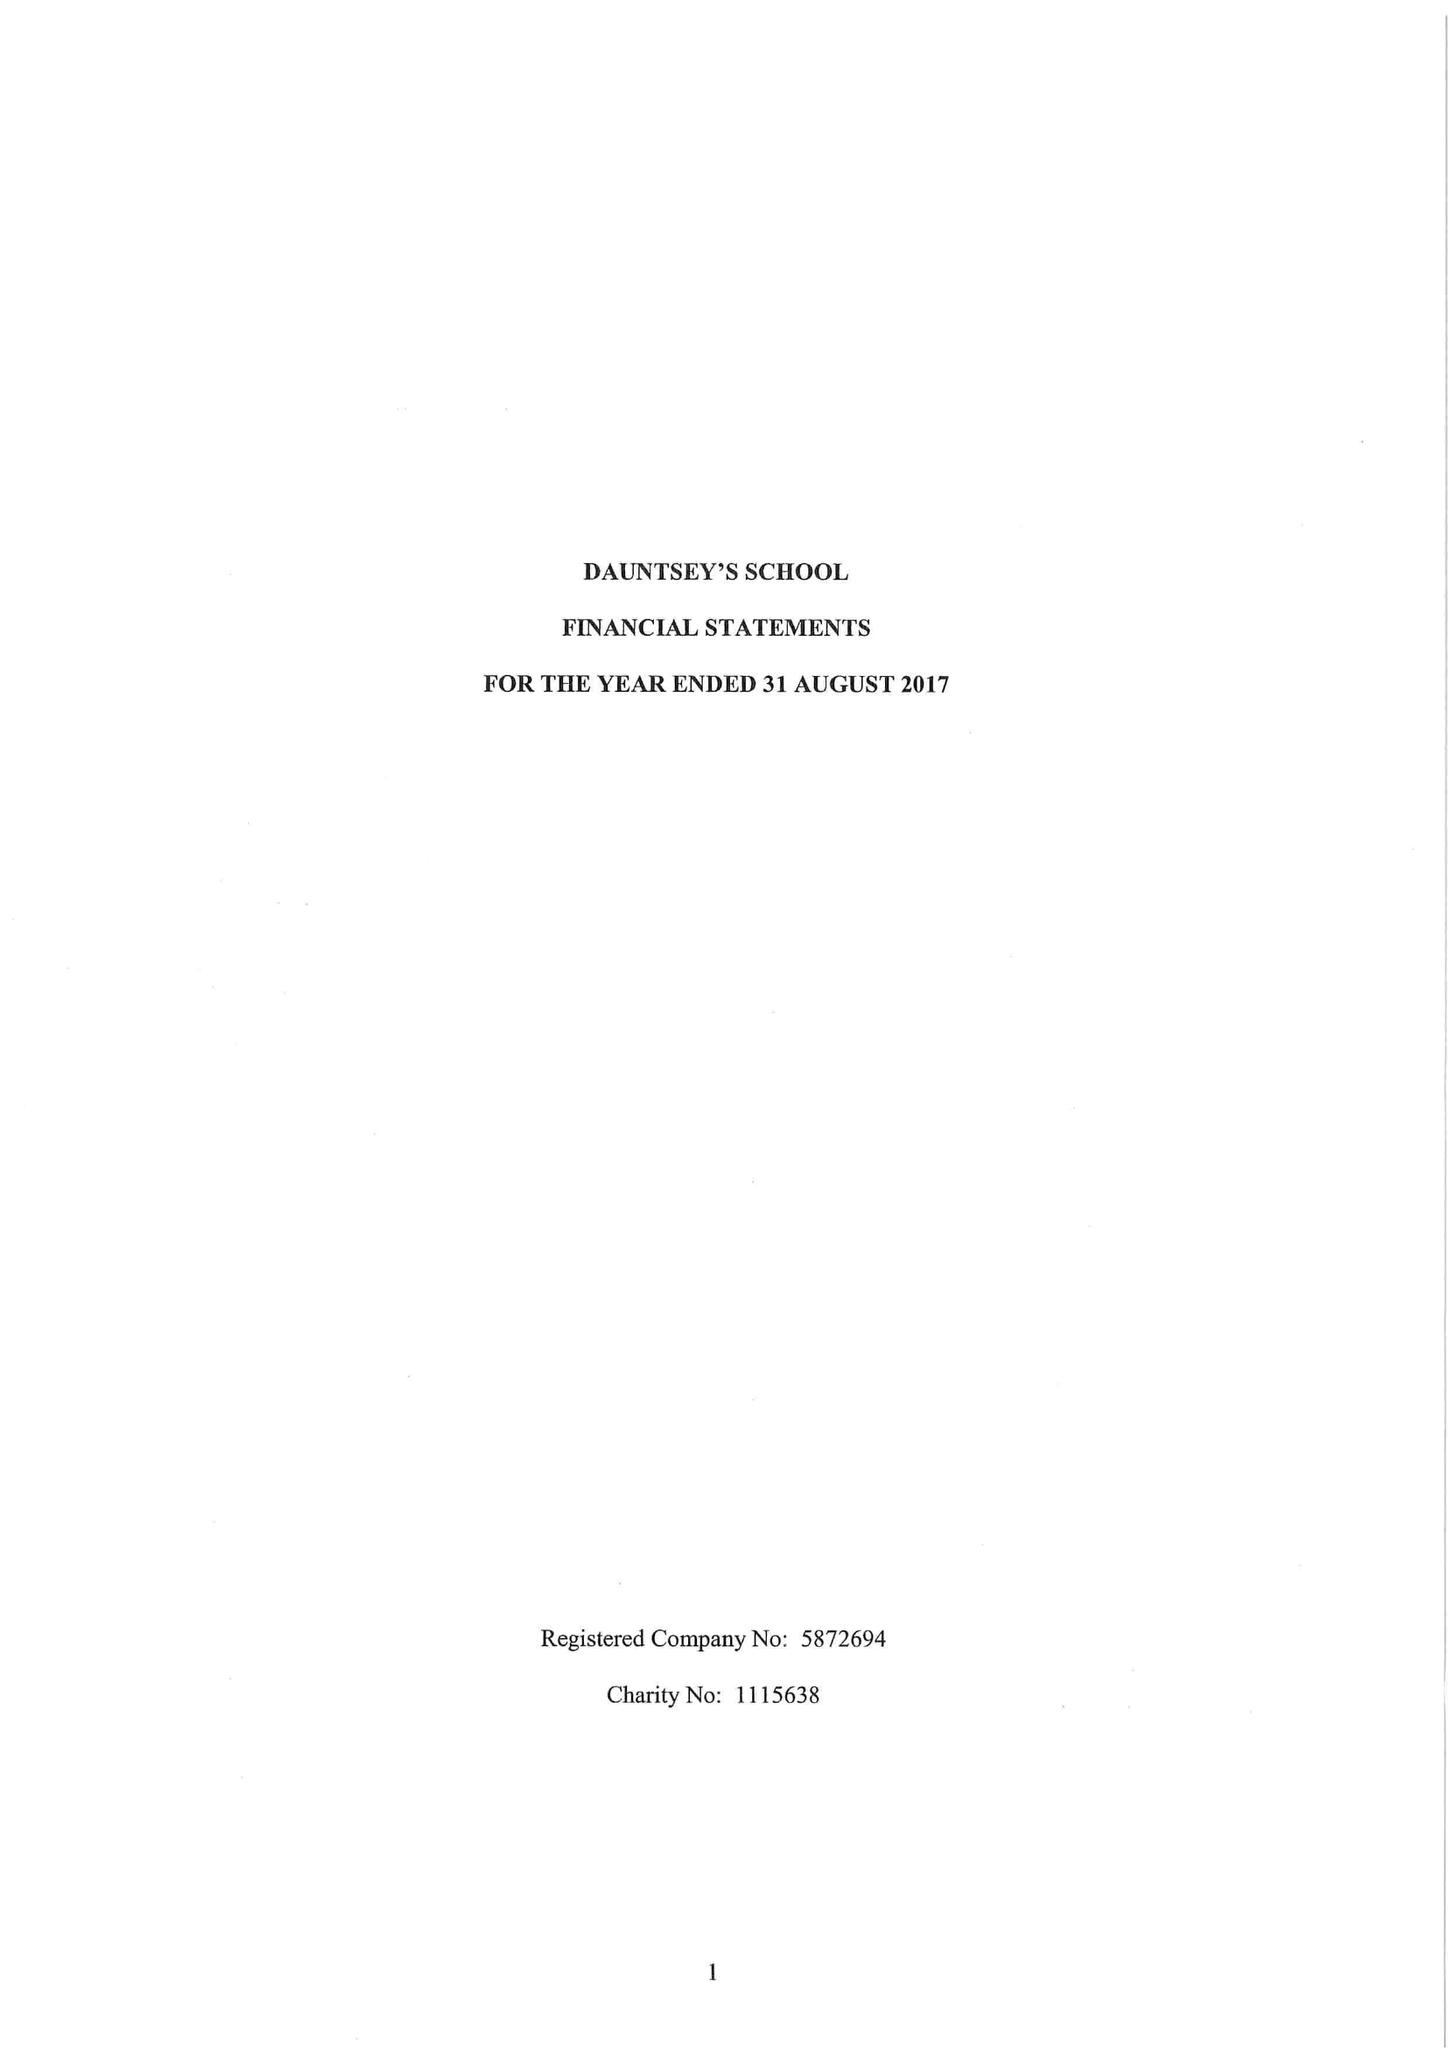What is the value for the address__post_town?
Answer the question using a single word or phrase. DEVIZES 